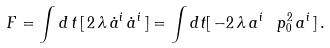<formula> <loc_0><loc_0><loc_500><loc_500>F = \int d \, t \, [ \, 2 \, \lambda \, \dot { a } ^ { i } \, \dot { a } ^ { i } \, ] = \int d t [ \, - 2 \, \lambda \, a ^ { i } \, \ p ^ { 2 } _ { 0 } \, a ^ { i } \, ] \, .</formula> 